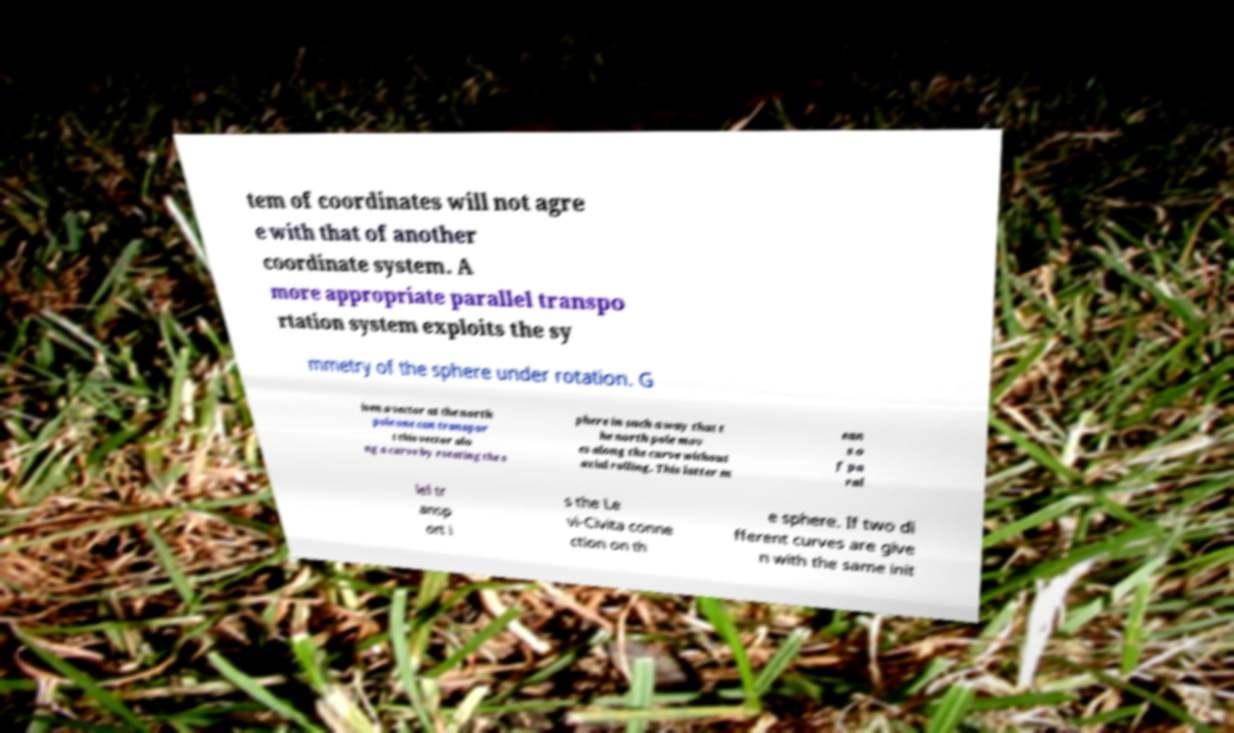For documentation purposes, I need the text within this image transcribed. Could you provide that? tem of coordinates will not agre e with that of another coordinate system. A more appropriate parallel transpo rtation system exploits the sy mmetry of the sphere under rotation. G iven a vector at the north pole one can transpor t this vector alo ng a curve by rotating the s phere in such a way that t he north pole mov es along the curve without axial rolling. This latter m ean s o f pa ral lel tr ansp ort i s the Le vi-Civita conne ction on th e sphere. If two di fferent curves are give n with the same init 